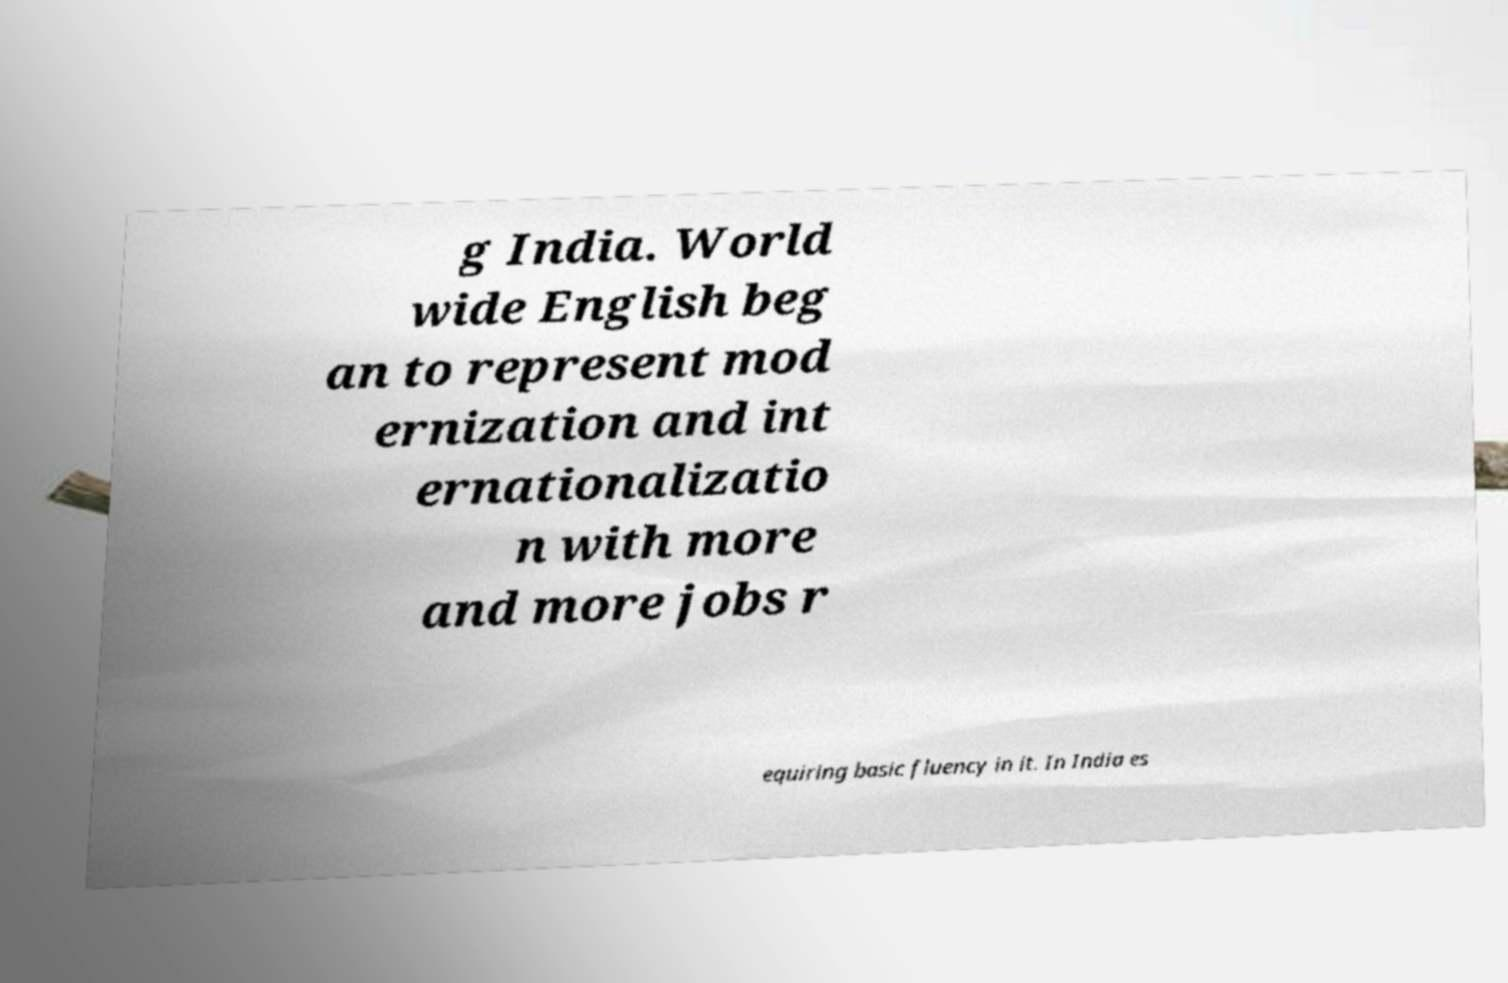Could you assist in decoding the text presented in this image and type it out clearly? g India. World wide English beg an to represent mod ernization and int ernationalizatio n with more and more jobs r equiring basic fluency in it. In India es 